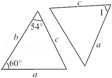Can triangles ABC and DEF be used to demonstrate any specific geometric principles? Yes, these triangles can be used to demonstrate several geometric principles such as the Side-Angle-Side (SAS) Congruence Theorem, Angle-Side-Angle (ASA) Postulate, and properties related to angle sum in triangles. They provide a practical example for understanding how triangles can be congruent based on specific side lengths and angle measures. 